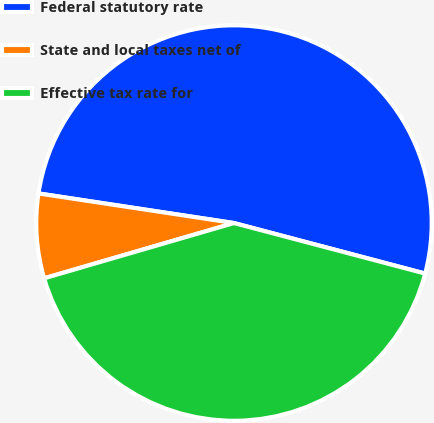<chart> <loc_0><loc_0><loc_500><loc_500><pie_chart><fcel>Federal statutory rate<fcel>State and local taxes net of<fcel>Effective tax rate for<nl><fcel>51.72%<fcel>6.9%<fcel>41.38%<nl></chart> 